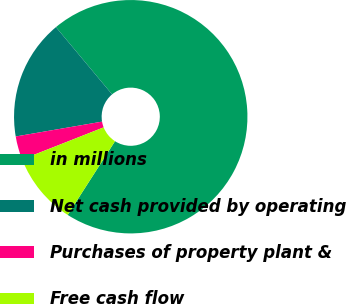Convert chart to OTSL. <chart><loc_0><loc_0><loc_500><loc_500><pie_chart><fcel>in millions<fcel>Net cash provided by operating<fcel>Purchases of property plant &<fcel>Free cash flow<nl><fcel>70.16%<fcel>16.64%<fcel>3.26%<fcel>9.95%<nl></chart> 